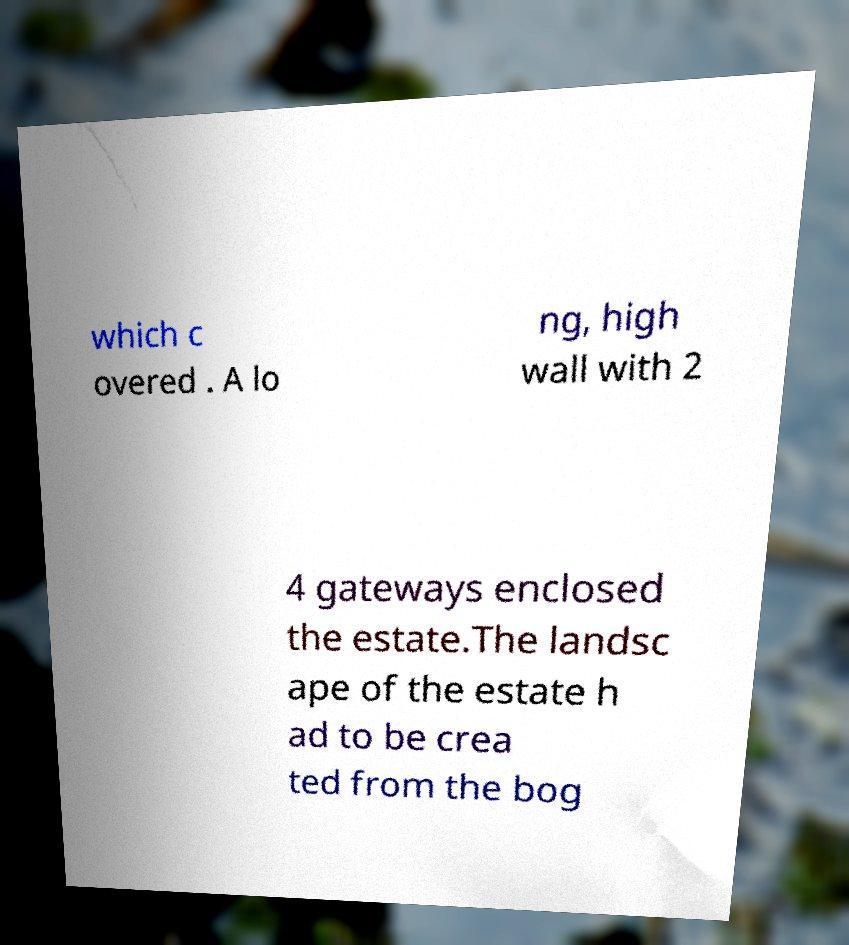Can you read and provide the text displayed in the image?This photo seems to have some interesting text. Can you extract and type it out for me? which c overed . A lo ng, high wall with 2 4 gateways enclosed the estate.The landsc ape of the estate h ad to be crea ted from the bog 